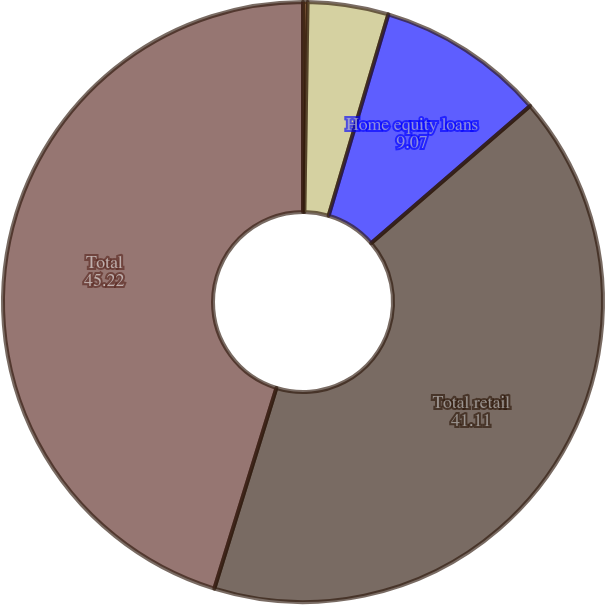<chart> <loc_0><loc_0><loc_500><loc_500><pie_chart><fcel>Total commercial<fcel>Residential mortgages<fcel>Home equity loans<fcel>Total retail<fcel>Total<nl><fcel>0.24%<fcel>4.35%<fcel>9.07%<fcel>41.11%<fcel>45.22%<nl></chart> 